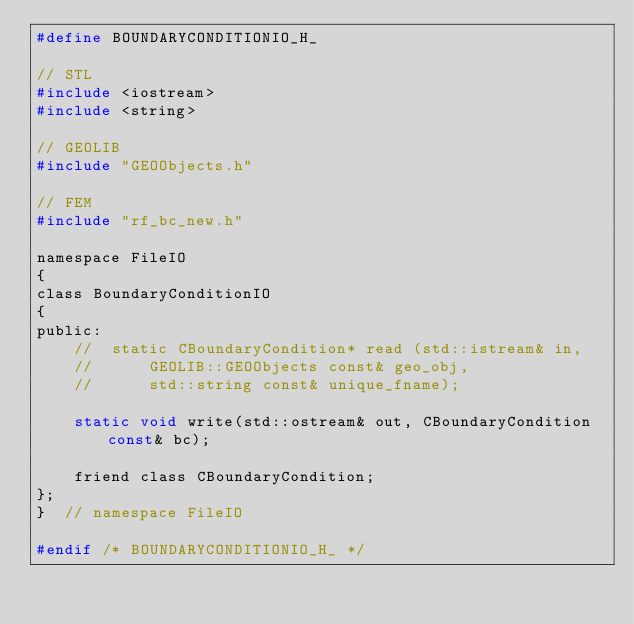<code> <loc_0><loc_0><loc_500><loc_500><_C_>#define BOUNDARYCONDITIONIO_H_

// STL
#include <iostream>
#include <string>

// GEOLIB
#include "GEOObjects.h"

// FEM
#include "rf_bc_new.h"

namespace FileIO
{
class BoundaryConditionIO
{
public:
    //	static CBoundaryCondition* read (std::istream& in,
    //			GEOLIB::GEOObjects const& geo_obj,
    //			std::string const& unique_fname);

    static void write(std::ostream& out, CBoundaryCondition const& bc);

    friend class CBoundaryCondition;
};
}  // namespace FileIO

#endif /* BOUNDARYCONDITIONIO_H_ */
</code> 